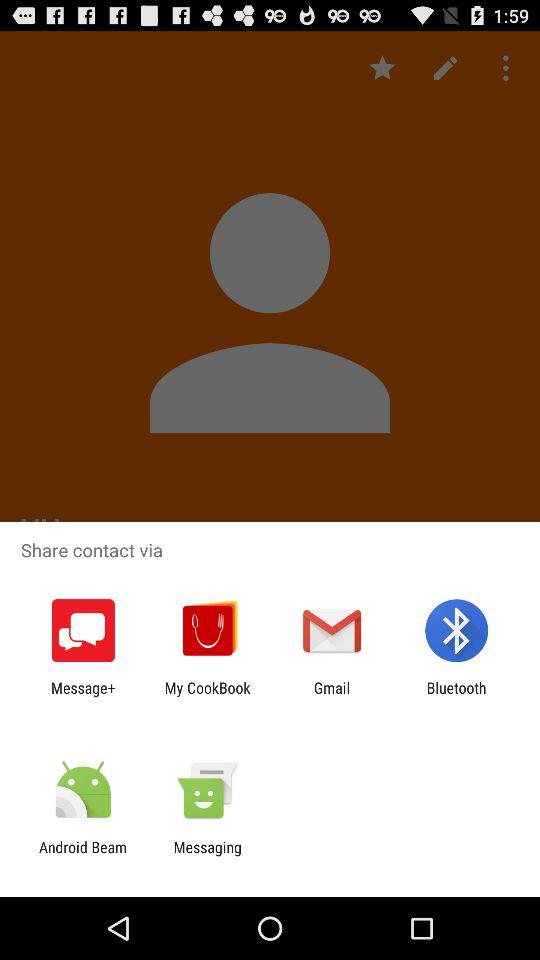Through what applications can we share contact with? The applications are "Message+", "My CookBook", "Gmail", "Bluetooth", "Android Beam" and "Messaging". 